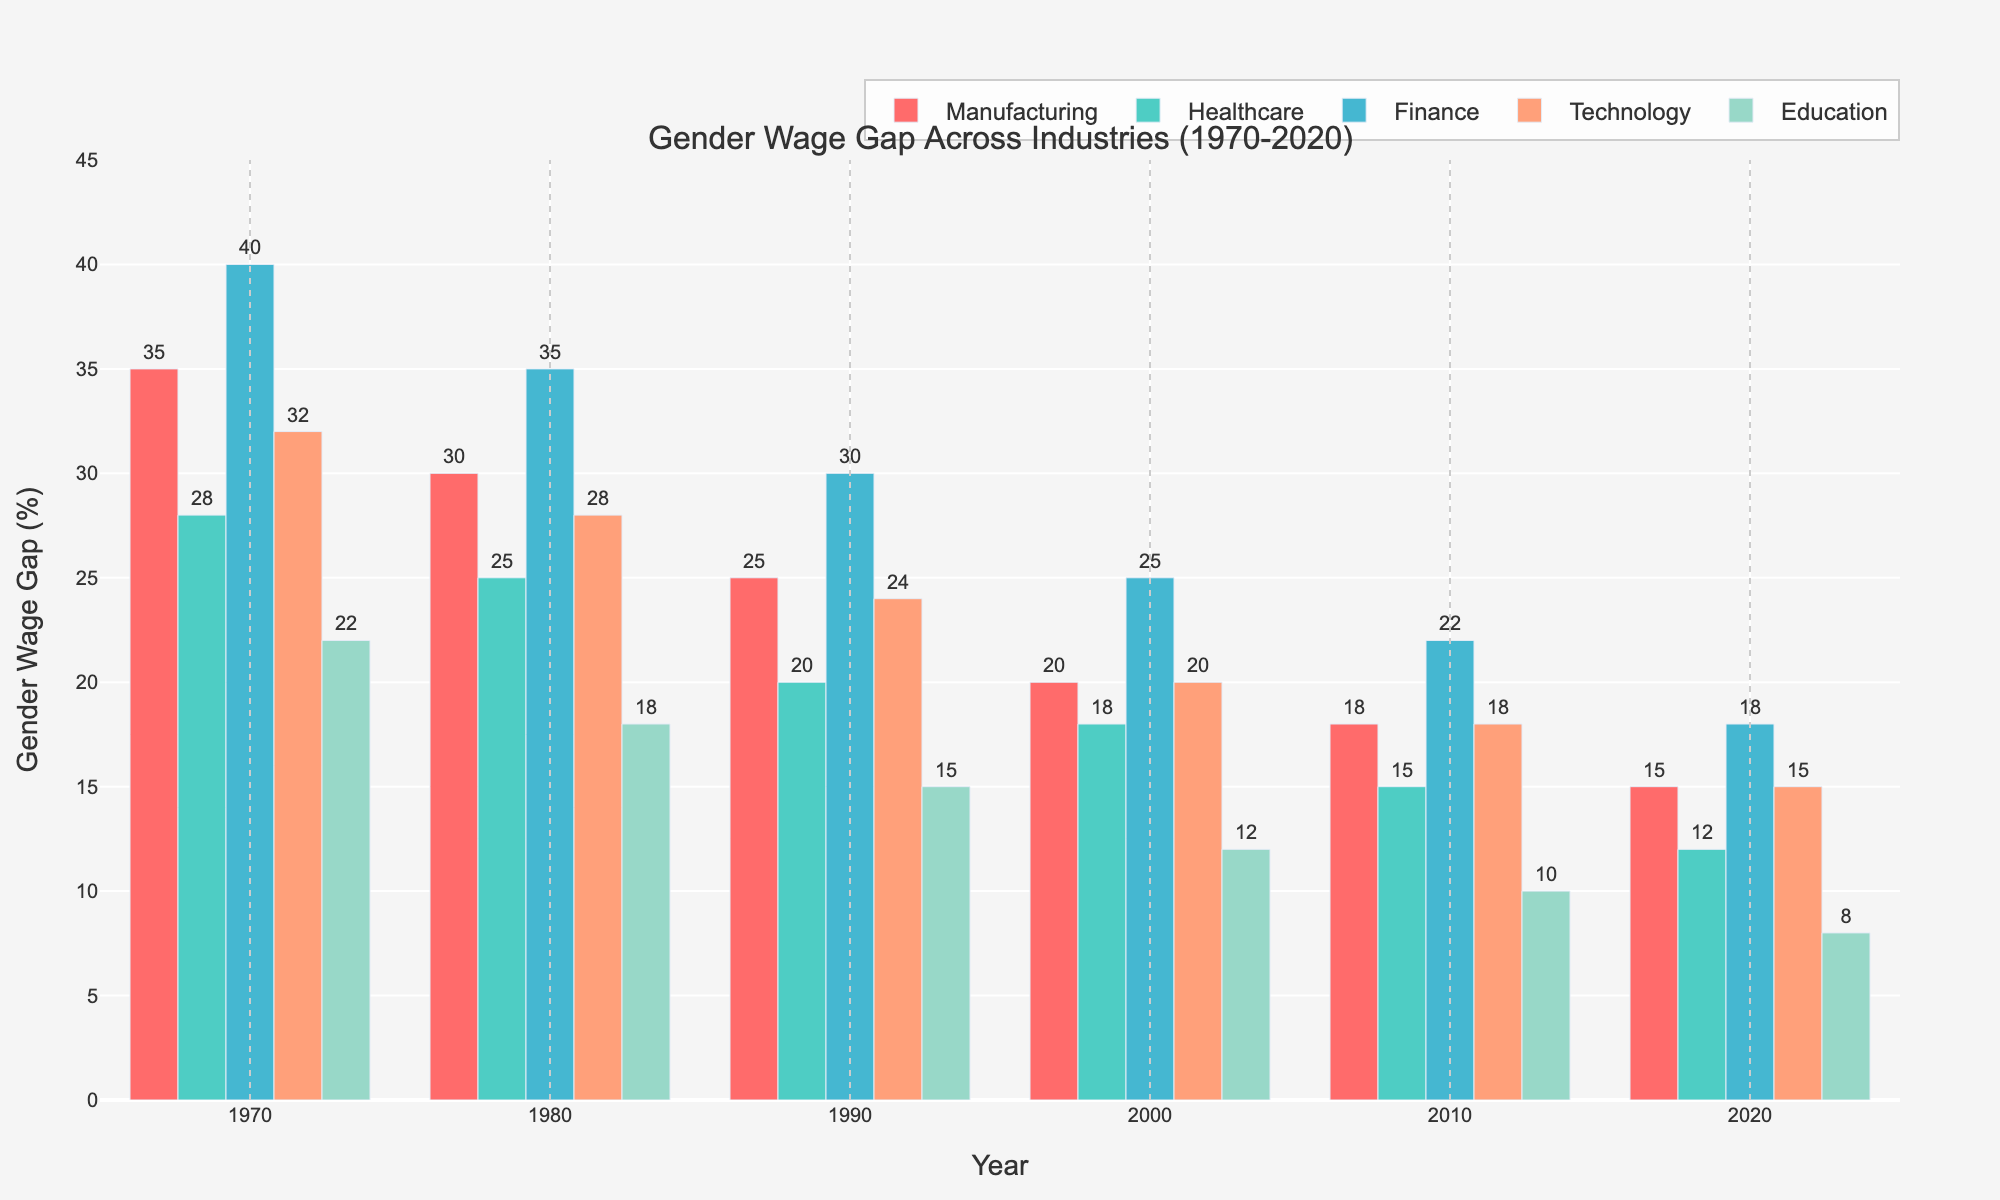What's the industry with the highest gender wage gap in 1970? Look at the bars for the year 1970 and find the one with the greatest height. In 1970, Finance has the highest bar, representing the highest gender wage gap.
Answer: Finance By how much did the gender wage gap in Healthcare decrease from 1970 to 2020? Find the bar representing Healthcare in 1970 and the one in 2020. The value for 1970 is 28 and for 2020 is 12. Subtract 12 from 28 (28 - 12 = 16).
Answer: 16 What was the average gender wage gap in 1990 across all industries? For 1990, add up the values for all industries (25 + 20 + 30 + 24 + 15 = 114) and divide by the number of industries (5). So, the average is 114/5 = 22.8
Answer: 22.8 Which industry showed the largest decrease in the gender wage gap from 1970 to 2020? Calculate the decrease for each industry by subtracting the 2020 value from the 1970 value. Manufacturing (35 - 15 = 20), Healthcare (28 - 12 = 16), Finance (40 - 18 = 22), Technology (32 - 15 = 17), Education (22 - 8 = 14). The largest decrease is in Finance (22).
Answer: Finance Compare the gender wage gap between Technology and Education in 2010. Which was higher and by how much? Find the bars for Technology and Education for 2010. Technology is 18 and Education is 10. Subtract 10 from 18 (18 - 10 = 8). Technology has a higher gap by 8.
Answer: Technology by 8 How did the gender wage gap change in the Manufacturing industry between 1980 and 2000? Look at the bars for Manufacturing in 1980 (30) and 2000 (20). Subtract 20 from 30 (30 - 20 = 10). The gap decreased by 10.
Answer: Decreased by 10 What's the trend of the gender wage gap in Education from 1970 to 2020? Observe the bars for Education over the years. They are consistently decreasing: 22 (1970), 18 (1980), 15 (1990), 12 (2000), 10 (2010), 8 (2020). The trend is a continuous decrease.
Answer: Continuous decrease Was the gender wage gap in Finance ever less than the gap in Manufacturing from 1970 to 2020? Compare the bars for Finance and Manufacturing for each year. Manufacturing was always lower or equal, but never less than Finance.
Answer: No In which industry did the gender wage gap remain consistently the lowest from 1970 to 2020? Identify the lowest bar for each year and check if it's consistently from the same industry. Education's bars are always the lowest or among the lowest, continuously moving downward.
Answer: Education 